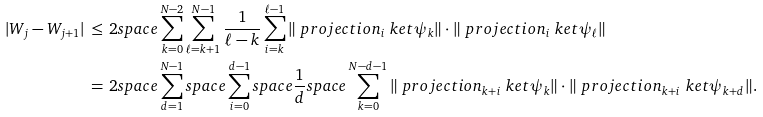Convert formula to latex. <formula><loc_0><loc_0><loc_500><loc_500>| W _ { j } - W _ { j + 1 } | & \, \leq \, 2 s p a c e \sum _ { k = 0 } ^ { N - 2 } \sum _ { \ell = k + 1 } ^ { N - 1 } \frac { 1 } { \ell - k } \sum _ { i = k } ^ { \ell - 1 } \| \ p r o j e c t i o n _ { i } \ k e t { \psi _ { k } } \| \cdot \| \ p r o j e c t i o n _ { i } \ k e t { \psi _ { \ell } } \| \\ & \, = \, 2 s p a c e \sum _ { d = 1 } ^ { N - 1 } s p a c e \sum _ { i = 0 } ^ { d - 1 } s p a c e \frac { 1 } { d } s p a c e \sum _ { k = 0 } ^ { N - d - 1 } \| \ p r o j e c t i o n _ { k + i } \ k e t { \psi _ { k } } \| \cdot \| \ p r o j e c t i o n _ { k + i } \ k e t { \psi _ { k + d } } \| .</formula> 